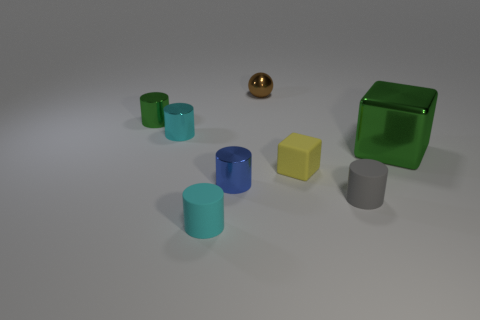How many objects are small things that are to the right of the tiny green metallic cylinder or cyan things in front of the large green block?
Your answer should be very brief. 6. Are there more matte blocks on the right side of the tiny cyan shiny thing than big brown rubber spheres?
Your response must be concise. Yes. How many other things are the same shape as the tiny gray matte thing?
Offer a very short reply. 4. What is the cylinder that is behind the yellow object and in front of the green metal cylinder made of?
Keep it short and to the point. Metal. What number of objects are either tiny purple metallic balls or cyan cylinders?
Ensure brevity in your answer.  2. Is the number of blue matte things greater than the number of small matte cylinders?
Provide a succinct answer. No. What is the size of the rubber cylinder that is right of the metallic cylinder in front of the yellow rubber object?
Provide a succinct answer. Small. There is another rubber object that is the same shape as the cyan matte thing; what is its color?
Give a very brief answer. Gray. The brown sphere has what size?
Your answer should be very brief. Small. How many spheres are either cyan metal objects or large green metallic things?
Offer a terse response. 0. 